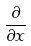<formula> <loc_0><loc_0><loc_500><loc_500>\frac { \partial } { \partial x }</formula> 